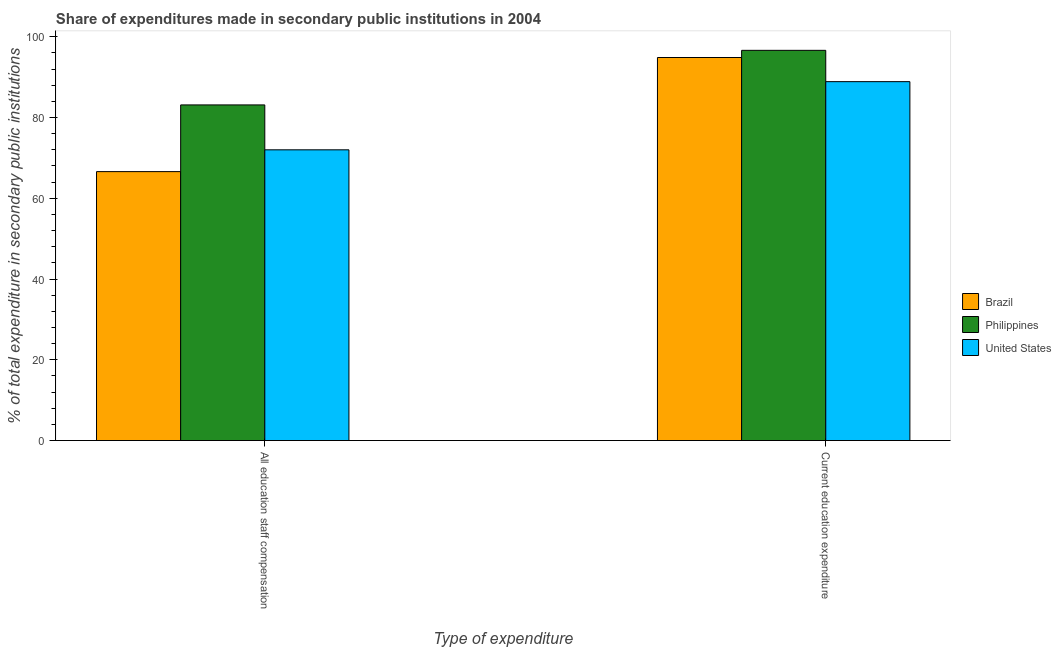How many different coloured bars are there?
Provide a short and direct response. 3. Are the number of bars on each tick of the X-axis equal?
Offer a terse response. Yes. How many bars are there on the 1st tick from the left?
Ensure brevity in your answer.  3. How many bars are there on the 1st tick from the right?
Offer a terse response. 3. What is the label of the 2nd group of bars from the left?
Give a very brief answer. Current education expenditure. What is the expenditure in education in United States?
Keep it short and to the point. 88.89. Across all countries, what is the maximum expenditure in staff compensation?
Keep it short and to the point. 83.12. Across all countries, what is the minimum expenditure in education?
Keep it short and to the point. 88.89. In which country was the expenditure in education maximum?
Your answer should be compact. Philippines. What is the total expenditure in education in the graph?
Offer a very short reply. 280.39. What is the difference between the expenditure in staff compensation in Philippines and that in United States?
Make the answer very short. 11.12. What is the difference between the expenditure in education in United States and the expenditure in staff compensation in Philippines?
Keep it short and to the point. 5.76. What is the average expenditure in staff compensation per country?
Keep it short and to the point. 73.91. What is the difference between the expenditure in staff compensation and expenditure in education in Philippines?
Ensure brevity in your answer.  -13.52. In how many countries, is the expenditure in staff compensation greater than 24 %?
Your response must be concise. 3. What is the ratio of the expenditure in staff compensation in United States to that in Philippines?
Ensure brevity in your answer.  0.87. What does the 1st bar from the left in Current education expenditure represents?
Your answer should be compact. Brazil. How many bars are there?
Provide a short and direct response. 6. Are all the bars in the graph horizontal?
Your response must be concise. No. What is the difference between two consecutive major ticks on the Y-axis?
Give a very brief answer. 20. Are the values on the major ticks of Y-axis written in scientific E-notation?
Offer a terse response. No. Does the graph contain any zero values?
Ensure brevity in your answer.  No. Where does the legend appear in the graph?
Your answer should be compact. Center right. How are the legend labels stacked?
Provide a short and direct response. Vertical. What is the title of the graph?
Your answer should be very brief. Share of expenditures made in secondary public institutions in 2004. What is the label or title of the X-axis?
Your response must be concise. Type of expenditure. What is the label or title of the Y-axis?
Keep it short and to the point. % of total expenditure in secondary public institutions. What is the % of total expenditure in secondary public institutions of Brazil in All education staff compensation?
Offer a very short reply. 66.61. What is the % of total expenditure in secondary public institutions in Philippines in All education staff compensation?
Ensure brevity in your answer.  83.12. What is the % of total expenditure in secondary public institutions in United States in All education staff compensation?
Provide a succinct answer. 72.01. What is the % of total expenditure in secondary public institutions in Brazil in Current education expenditure?
Give a very brief answer. 94.86. What is the % of total expenditure in secondary public institutions in Philippines in Current education expenditure?
Provide a short and direct response. 96.64. What is the % of total expenditure in secondary public institutions of United States in Current education expenditure?
Your answer should be very brief. 88.89. Across all Type of expenditure, what is the maximum % of total expenditure in secondary public institutions of Brazil?
Ensure brevity in your answer.  94.86. Across all Type of expenditure, what is the maximum % of total expenditure in secondary public institutions in Philippines?
Offer a terse response. 96.64. Across all Type of expenditure, what is the maximum % of total expenditure in secondary public institutions in United States?
Your answer should be very brief. 88.89. Across all Type of expenditure, what is the minimum % of total expenditure in secondary public institutions of Brazil?
Your answer should be compact. 66.61. Across all Type of expenditure, what is the minimum % of total expenditure in secondary public institutions in Philippines?
Offer a very short reply. 83.12. Across all Type of expenditure, what is the minimum % of total expenditure in secondary public institutions in United States?
Offer a very short reply. 72.01. What is the total % of total expenditure in secondary public institutions of Brazil in the graph?
Make the answer very short. 161.47. What is the total % of total expenditure in secondary public institutions in Philippines in the graph?
Your response must be concise. 179.77. What is the total % of total expenditure in secondary public institutions of United States in the graph?
Your answer should be very brief. 160.89. What is the difference between the % of total expenditure in secondary public institutions in Brazil in All education staff compensation and that in Current education expenditure?
Your response must be concise. -28.26. What is the difference between the % of total expenditure in secondary public institutions of Philippines in All education staff compensation and that in Current education expenditure?
Offer a terse response. -13.52. What is the difference between the % of total expenditure in secondary public institutions in United States in All education staff compensation and that in Current education expenditure?
Offer a very short reply. -16.88. What is the difference between the % of total expenditure in secondary public institutions of Brazil in All education staff compensation and the % of total expenditure in secondary public institutions of Philippines in Current education expenditure?
Your answer should be compact. -30.03. What is the difference between the % of total expenditure in secondary public institutions of Brazil in All education staff compensation and the % of total expenditure in secondary public institutions of United States in Current education expenditure?
Give a very brief answer. -22.28. What is the difference between the % of total expenditure in secondary public institutions in Philippines in All education staff compensation and the % of total expenditure in secondary public institutions in United States in Current education expenditure?
Give a very brief answer. -5.76. What is the average % of total expenditure in secondary public institutions of Brazil per Type of expenditure?
Ensure brevity in your answer.  80.74. What is the average % of total expenditure in secondary public institutions in Philippines per Type of expenditure?
Your response must be concise. 89.88. What is the average % of total expenditure in secondary public institutions of United States per Type of expenditure?
Give a very brief answer. 80.45. What is the difference between the % of total expenditure in secondary public institutions of Brazil and % of total expenditure in secondary public institutions of Philippines in All education staff compensation?
Give a very brief answer. -16.52. What is the difference between the % of total expenditure in secondary public institutions in Brazil and % of total expenditure in secondary public institutions in United States in All education staff compensation?
Offer a very short reply. -5.4. What is the difference between the % of total expenditure in secondary public institutions of Philippines and % of total expenditure in secondary public institutions of United States in All education staff compensation?
Make the answer very short. 11.12. What is the difference between the % of total expenditure in secondary public institutions of Brazil and % of total expenditure in secondary public institutions of Philippines in Current education expenditure?
Offer a terse response. -1.78. What is the difference between the % of total expenditure in secondary public institutions in Brazil and % of total expenditure in secondary public institutions in United States in Current education expenditure?
Your answer should be very brief. 5.98. What is the difference between the % of total expenditure in secondary public institutions of Philippines and % of total expenditure in secondary public institutions of United States in Current education expenditure?
Your answer should be very brief. 7.75. What is the ratio of the % of total expenditure in secondary public institutions of Brazil in All education staff compensation to that in Current education expenditure?
Your response must be concise. 0.7. What is the ratio of the % of total expenditure in secondary public institutions in Philippines in All education staff compensation to that in Current education expenditure?
Provide a short and direct response. 0.86. What is the ratio of the % of total expenditure in secondary public institutions of United States in All education staff compensation to that in Current education expenditure?
Ensure brevity in your answer.  0.81. What is the difference between the highest and the second highest % of total expenditure in secondary public institutions in Brazil?
Offer a very short reply. 28.26. What is the difference between the highest and the second highest % of total expenditure in secondary public institutions of Philippines?
Ensure brevity in your answer.  13.52. What is the difference between the highest and the second highest % of total expenditure in secondary public institutions of United States?
Provide a short and direct response. 16.88. What is the difference between the highest and the lowest % of total expenditure in secondary public institutions of Brazil?
Provide a short and direct response. 28.26. What is the difference between the highest and the lowest % of total expenditure in secondary public institutions of Philippines?
Make the answer very short. 13.52. What is the difference between the highest and the lowest % of total expenditure in secondary public institutions of United States?
Your answer should be very brief. 16.88. 